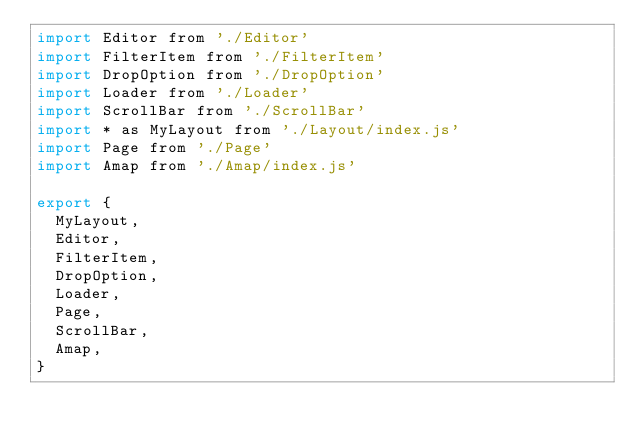Convert code to text. <code><loc_0><loc_0><loc_500><loc_500><_JavaScript_>import Editor from './Editor'
import FilterItem from './FilterItem'
import DropOption from './DropOption'
import Loader from './Loader'
import ScrollBar from './ScrollBar'
import * as MyLayout from './Layout/index.js'
import Page from './Page'
import Amap from './Amap/index.js'

export {
  MyLayout,
  Editor,
  FilterItem,
  DropOption,
  Loader,
  Page,
  ScrollBar,
  Amap,
}
</code> 